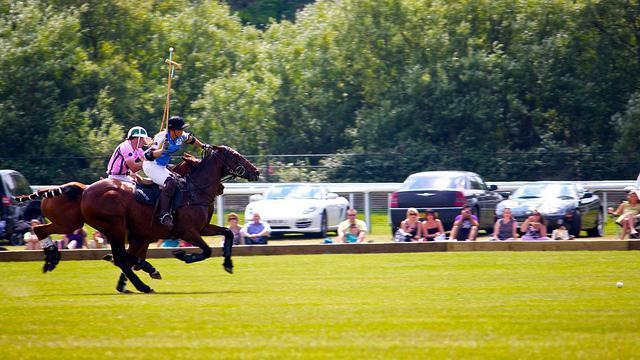How many cars are there?
Give a very brief answer. 3. How many skis are there?
Give a very brief answer. 0. 